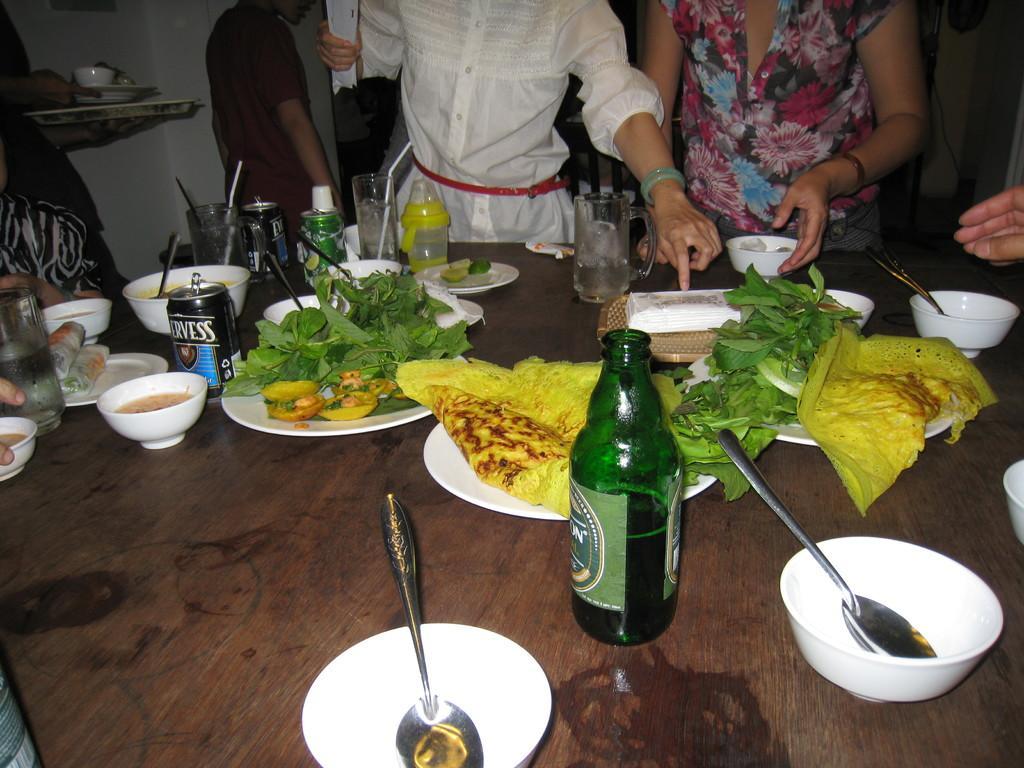What is the main subject of the image? The main subject of the image is a table full of food. Are there any people present in the image? Yes, there is a group of people standing in the image. What is the purpose of the people being present in the image? The people are present to eat the food. What type of wax can be seen melting on the table in the image? There is no wax present in the image; it features a table full of food and a group of people. 